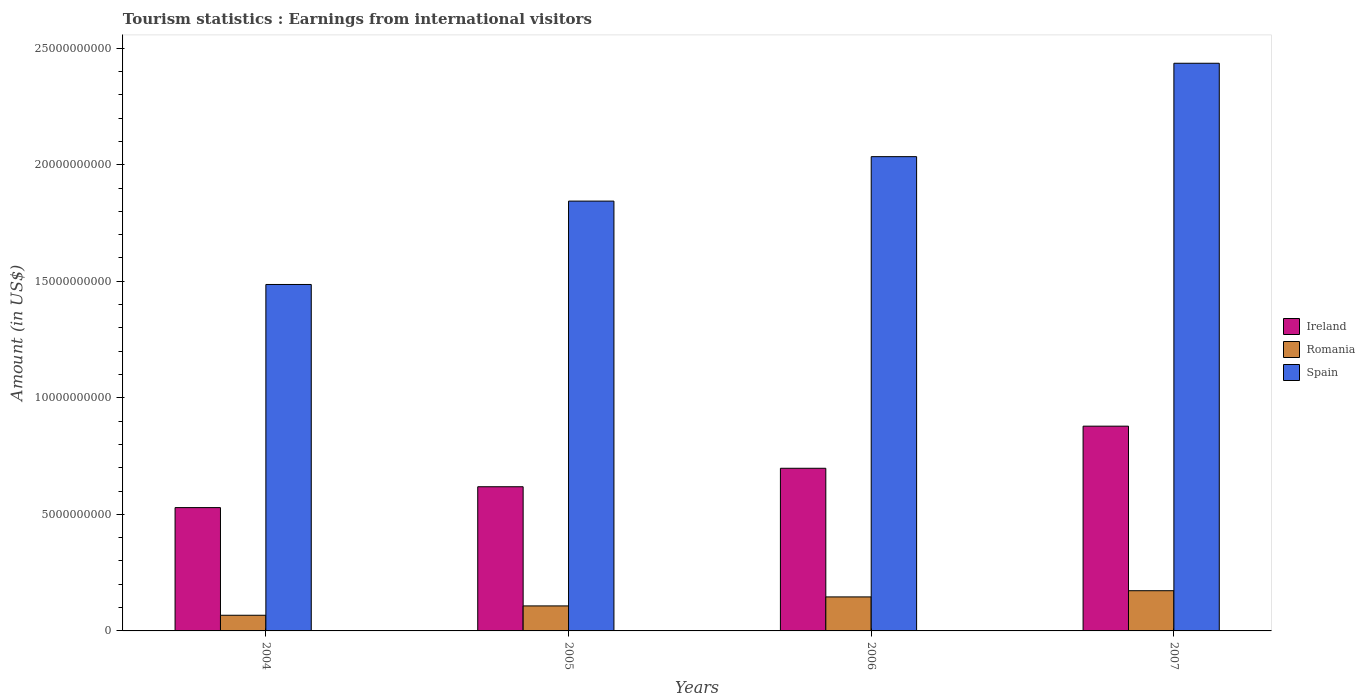Are the number of bars per tick equal to the number of legend labels?
Your answer should be very brief. Yes. How many bars are there on the 4th tick from the left?
Make the answer very short. 3. How many bars are there on the 3rd tick from the right?
Provide a succinct answer. 3. In how many cases, is the number of bars for a given year not equal to the number of legend labels?
Your answer should be compact. 0. What is the earnings from international visitors in Romania in 2006?
Provide a succinct answer. 1.46e+09. Across all years, what is the maximum earnings from international visitors in Romania?
Offer a very short reply. 1.72e+09. Across all years, what is the minimum earnings from international visitors in Spain?
Ensure brevity in your answer.  1.49e+1. What is the total earnings from international visitors in Romania in the graph?
Provide a short and direct response. 4.93e+09. What is the difference between the earnings from international visitors in Romania in 2004 and that in 2005?
Your answer should be very brief. -4.01e+08. What is the difference between the earnings from international visitors in Ireland in 2007 and the earnings from international visitors in Romania in 2005?
Your answer should be very brief. 7.71e+09. What is the average earnings from international visitors in Romania per year?
Your answer should be very brief. 1.23e+09. In the year 2006, what is the difference between the earnings from international visitors in Spain and earnings from international visitors in Ireland?
Give a very brief answer. 1.34e+1. In how many years, is the earnings from international visitors in Romania greater than 5000000000 US$?
Provide a short and direct response. 0. What is the ratio of the earnings from international visitors in Spain in 2005 to that in 2007?
Ensure brevity in your answer.  0.76. Is the difference between the earnings from international visitors in Spain in 2004 and 2006 greater than the difference between the earnings from international visitors in Ireland in 2004 and 2006?
Your response must be concise. No. What is the difference between the highest and the second highest earnings from international visitors in Romania?
Offer a very short reply. 2.66e+08. What is the difference between the highest and the lowest earnings from international visitors in Ireland?
Provide a short and direct response. 3.49e+09. In how many years, is the earnings from international visitors in Ireland greater than the average earnings from international visitors in Ireland taken over all years?
Make the answer very short. 2. Is the sum of the earnings from international visitors in Romania in 2004 and 2007 greater than the maximum earnings from international visitors in Spain across all years?
Keep it short and to the point. No. What does the 2nd bar from the left in 2006 represents?
Offer a terse response. Romania. What does the 3rd bar from the right in 2005 represents?
Keep it short and to the point. Ireland. Is it the case that in every year, the sum of the earnings from international visitors in Ireland and earnings from international visitors in Romania is greater than the earnings from international visitors in Spain?
Keep it short and to the point. No. Are the values on the major ticks of Y-axis written in scientific E-notation?
Your answer should be compact. No. Where does the legend appear in the graph?
Your answer should be compact. Center right. How many legend labels are there?
Offer a very short reply. 3. What is the title of the graph?
Your response must be concise. Tourism statistics : Earnings from international visitors. Does "Morocco" appear as one of the legend labels in the graph?
Your response must be concise. No. What is the label or title of the Y-axis?
Offer a very short reply. Amount (in US$). What is the Amount (in US$) in Ireland in 2004?
Offer a terse response. 5.29e+09. What is the Amount (in US$) in Romania in 2004?
Offer a very short reply. 6.72e+08. What is the Amount (in US$) in Spain in 2004?
Your answer should be very brief. 1.49e+1. What is the Amount (in US$) in Ireland in 2005?
Provide a short and direct response. 6.19e+09. What is the Amount (in US$) of Romania in 2005?
Make the answer very short. 1.07e+09. What is the Amount (in US$) of Spain in 2005?
Your answer should be compact. 1.84e+1. What is the Amount (in US$) of Ireland in 2006?
Your answer should be compact. 6.98e+09. What is the Amount (in US$) of Romania in 2006?
Give a very brief answer. 1.46e+09. What is the Amount (in US$) in Spain in 2006?
Offer a terse response. 2.03e+1. What is the Amount (in US$) in Ireland in 2007?
Keep it short and to the point. 8.78e+09. What is the Amount (in US$) of Romania in 2007?
Your response must be concise. 1.72e+09. What is the Amount (in US$) in Spain in 2007?
Your answer should be very brief. 2.44e+1. Across all years, what is the maximum Amount (in US$) of Ireland?
Make the answer very short. 8.78e+09. Across all years, what is the maximum Amount (in US$) of Romania?
Provide a succinct answer. 1.72e+09. Across all years, what is the maximum Amount (in US$) of Spain?
Keep it short and to the point. 2.44e+1. Across all years, what is the minimum Amount (in US$) of Ireland?
Offer a terse response. 5.29e+09. Across all years, what is the minimum Amount (in US$) of Romania?
Give a very brief answer. 6.72e+08. Across all years, what is the minimum Amount (in US$) of Spain?
Offer a very short reply. 1.49e+1. What is the total Amount (in US$) of Ireland in the graph?
Provide a short and direct response. 2.72e+1. What is the total Amount (in US$) of Romania in the graph?
Provide a short and direct response. 4.93e+09. What is the total Amount (in US$) in Spain in the graph?
Make the answer very short. 7.80e+1. What is the difference between the Amount (in US$) in Ireland in 2004 and that in 2005?
Keep it short and to the point. -8.95e+08. What is the difference between the Amount (in US$) of Romania in 2004 and that in 2005?
Offer a terse response. -4.01e+08. What is the difference between the Amount (in US$) of Spain in 2004 and that in 2005?
Give a very brief answer. -3.58e+09. What is the difference between the Amount (in US$) of Ireland in 2004 and that in 2006?
Offer a very short reply. -1.69e+09. What is the difference between the Amount (in US$) of Romania in 2004 and that in 2006?
Provide a short and direct response. -7.87e+08. What is the difference between the Amount (in US$) in Spain in 2004 and that in 2006?
Your answer should be compact. -5.48e+09. What is the difference between the Amount (in US$) in Ireland in 2004 and that in 2007?
Provide a succinct answer. -3.49e+09. What is the difference between the Amount (in US$) of Romania in 2004 and that in 2007?
Keep it short and to the point. -1.05e+09. What is the difference between the Amount (in US$) of Spain in 2004 and that in 2007?
Your response must be concise. -9.49e+09. What is the difference between the Amount (in US$) of Ireland in 2005 and that in 2006?
Provide a succinct answer. -7.92e+08. What is the difference between the Amount (in US$) of Romania in 2005 and that in 2006?
Provide a short and direct response. -3.86e+08. What is the difference between the Amount (in US$) in Spain in 2005 and that in 2006?
Your answer should be very brief. -1.91e+09. What is the difference between the Amount (in US$) of Ireland in 2005 and that in 2007?
Ensure brevity in your answer.  -2.60e+09. What is the difference between the Amount (in US$) of Romania in 2005 and that in 2007?
Offer a terse response. -6.52e+08. What is the difference between the Amount (in US$) in Spain in 2005 and that in 2007?
Give a very brief answer. -5.91e+09. What is the difference between the Amount (in US$) in Ireland in 2006 and that in 2007?
Ensure brevity in your answer.  -1.81e+09. What is the difference between the Amount (in US$) in Romania in 2006 and that in 2007?
Make the answer very short. -2.66e+08. What is the difference between the Amount (in US$) in Spain in 2006 and that in 2007?
Give a very brief answer. -4.01e+09. What is the difference between the Amount (in US$) in Ireland in 2004 and the Amount (in US$) in Romania in 2005?
Ensure brevity in your answer.  4.22e+09. What is the difference between the Amount (in US$) in Ireland in 2004 and the Amount (in US$) in Spain in 2005?
Offer a terse response. -1.32e+1. What is the difference between the Amount (in US$) in Romania in 2004 and the Amount (in US$) in Spain in 2005?
Provide a short and direct response. -1.78e+1. What is the difference between the Amount (in US$) in Ireland in 2004 and the Amount (in US$) in Romania in 2006?
Your answer should be very brief. 3.83e+09. What is the difference between the Amount (in US$) of Ireland in 2004 and the Amount (in US$) of Spain in 2006?
Give a very brief answer. -1.51e+1. What is the difference between the Amount (in US$) of Romania in 2004 and the Amount (in US$) of Spain in 2006?
Your answer should be compact. -1.97e+1. What is the difference between the Amount (in US$) of Ireland in 2004 and the Amount (in US$) of Romania in 2007?
Make the answer very short. 3.57e+09. What is the difference between the Amount (in US$) in Ireland in 2004 and the Amount (in US$) in Spain in 2007?
Provide a succinct answer. -1.91e+1. What is the difference between the Amount (in US$) of Romania in 2004 and the Amount (in US$) of Spain in 2007?
Provide a short and direct response. -2.37e+1. What is the difference between the Amount (in US$) in Ireland in 2005 and the Amount (in US$) in Romania in 2006?
Give a very brief answer. 4.73e+09. What is the difference between the Amount (in US$) in Ireland in 2005 and the Amount (in US$) in Spain in 2006?
Your answer should be compact. -1.42e+1. What is the difference between the Amount (in US$) in Romania in 2005 and the Amount (in US$) in Spain in 2006?
Your answer should be compact. -1.93e+1. What is the difference between the Amount (in US$) of Ireland in 2005 and the Amount (in US$) of Romania in 2007?
Your response must be concise. 4.46e+09. What is the difference between the Amount (in US$) in Ireland in 2005 and the Amount (in US$) in Spain in 2007?
Provide a succinct answer. -1.82e+1. What is the difference between the Amount (in US$) of Romania in 2005 and the Amount (in US$) of Spain in 2007?
Ensure brevity in your answer.  -2.33e+1. What is the difference between the Amount (in US$) of Ireland in 2006 and the Amount (in US$) of Romania in 2007?
Give a very brief answer. 5.25e+09. What is the difference between the Amount (in US$) of Ireland in 2006 and the Amount (in US$) of Spain in 2007?
Your answer should be compact. -1.74e+1. What is the difference between the Amount (in US$) in Romania in 2006 and the Amount (in US$) in Spain in 2007?
Give a very brief answer. -2.29e+1. What is the average Amount (in US$) in Ireland per year?
Ensure brevity in your answer.  6.81e+09. What is the average Amount (in US$) in Romania per year?
Your answer should be very brief. 1.23e+09. What is the average Amount (in US$) of Spain per year?
Offer a terse response. 1.95e+1. In the year 2004, what is the difference between the Amount (in US$) of Ireland and Amount (in US$) of Romania?
Provide a succinct answer. 4.62e+09. In the year 2004, what is the difference between the Amount (in US$) of Ireland and Amount (in US$) of Spain?
Provide a succinct answer. -9.57e+09. In the year 2004, what is the difference between the Amount (in US$) in Romania and Amount (in US$) in Spain?
Offer a terse response. -1.42e+1. In the year 2005, what is the difference between the Amount (in US$) of Ireland and Amount (in US$) of Romania?
Provide a short and direct response. 5.11e+09. In the year 2005, what is the difference between the Amount (in US$) in Ireland and Amount (in US$) in Spain?
Make the answer very short. -1.23e+1. In the year 2005, what is the difference between the Amount (in US$) in Romania and Amount (in US$) in Spain?
Make the answer very short. -1.74e+1. In the year 2006, what is the difference between the Amount (in US$) in Ireland and Amount (in US$) in Romania?
Provide a succinct answer. 5.52e+09. In the year 2006, what is the difference between the Amount (in US$) of Ireland and Amount (in US$) of Spain?
Your response must be concise. -1.34e+1. In the year 2006, what is the difference between the Amount (in US$) in Romania and Amount (in US$) in Spain?
Your response must be concise. -1.89e+1. In the year 2007, what is the difference between the Amount (in US$) of Ireland and Amount (in US$) of Romania?
Provide a succinct answer. 7.06e+09. In the year 2007, what is the difference between the Amount (in US$) of Ireland and Amount (in US$) of Spain?
Your response must be concise. -1.56e+1. In the year 2007, what is the difference between the Amount (in US$) of Romania and Amount (in US$) of Spain?
Make the answer very short. -2.26e+1. What is the ratio of the Amount (in US$) in Ireland in 2004 to that in 2005?
Offer a terse response. 0.86. What is the ratio of the Amount (in US$) of Romania in 2004 to that in 2005?
Make the answer very short. 0.63. What is the ratio of the Amount (in US$) in Spain in 2004 to that in 2005?
Your response must be concise. 0.81. What is the ratio of the Amount (in US$) of Ireland in 2004 to that in 2006?
Provide a succinct answer. 0.76. What is the ratio of the Amount (in US$) of Romania in 2004 to that in 2006?
Your answer should be very brief. 0.46. What is the ratio of the Amount (in US$) in Spain in 2004 to that in 2006?
Your answer should be very brief. 0.73. What is the ratio of the Amount (in US$) in Ireland in 2004 to that in 2007?
Provide a succinct answer. 0.6. What is the ratio of the Amount (in US$) in Romania in 2004 to that in 2007?
Provide a short and direct response. 0.39. What is the ratio of the Amount (in US$) in Spain in 2004 to that in 2007?
Give a very brief answer. 0.61. What is the ratio of the Amount (in US$) in Ireland in 2005 to that in 2006?
Make the answer very short. 0.89. What is the ratio of the Amount (in US$) in Romania in 2005 to that in 2006?
Provide a succinct answer. 0.74. What is the ratio of the Amount (in US$) of Spain in 2005 to that in 2006?
Your answer should be very brief. 0.91. What is the ratio of the Amount (in US$) of Ireland in 2005 to that in 2007?
Your answer should be very brief. 0.7. What is the ratio of the Amount (in US$) of Romania in 2005 to that in 2007?
Offer a terse response. 0.62. What is the ratio of the Amount (in US$) in Spain in 2005 to that in 2007?
Ensure brevity in your answer.  0.76. What is the ratio of the Amount (in US$) of Ireland in 2006 to that in 2007?
Offer a very short reply. 0.79. What is the ratio of the Amount (in US$) of Romania in 2006 to that in 2007?
Give a very brief answer. 0.85. What is the ratio of the Amount (in US$) in Spain in 2006 to that in 2007?
Provide a succinct answer. 0.84. What is the difference between the highest and the second highest Amount (in US$) of Ireland?
Your response must be concise. 1.81e+09. What is the difference between the highest and the second highest Amount (in US$) in Romania?
Your response must be concise. 2.66e+08. What is the difference between the highest and the second highest Amount (in US$) of Spain?
Give a very brief answer. 4.01e+09. What is the difference between the highest and the lowest Amount (in US$) in Ireland?
Offer a terse response. 3.49e+09. What is the difference between the highest and the lowest Amount (in US$) in Romania?
Provide a short and direct response. 1.05e+09. What is the difference between the highest and the lowest Amount (in US$) in Spain?
Your answer should be very brief. 9.49e+09. 